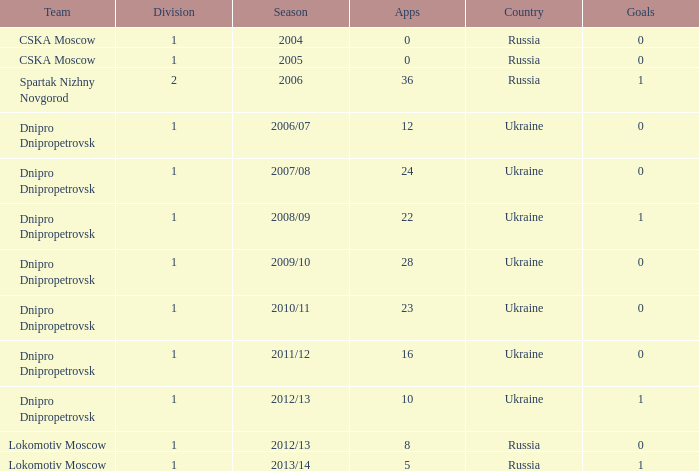Help me parse the entirety of this table. {'header': ['Team', 'Division', 'Season', 'Apps', 'Country', 'Goals'], 'rows': [['CSKA Moscow', '1', '2004', '0', 'Russia', '0'], ['CSKA Moscow', '1', '2005', '0', 'Russia', '0'], ['Spartak Nizhny Novgorod', '2', '2006', '36', 'Russia', '1'], ['Dnipro Dnipropetrovsk', '1', '2006/07', '12', 'Ukraine', '0'], ['Dnipro Dnipropetrovsk', '1', '2007/08', '24', 'Ukraine', '0'], ['Dnipro Dnipropetrovsk', '1', '2008/09', '22', 'Ukraine', '1'], ['Dnipro Dnipropetrovsk', '1', '2009/10', '28', 'Ukraine', '0'], ['Dnipro Dnipropetrovsk', '1', '2010/11', '23', 'Ukraine', '0'], ['Dnipro Dnipropetrovsk', '1', '2011/12', '16', 'Ukraine', '0'], ['Dnipro Dnipropetrovsk', '1', '2012/13', '10', 'Ukraine', '1'], ['Lokomotiv Moscow', '1', '2012/13', '8', 'Russia', '0'], ['Lokomotiv Moscow', '1', '2013/14', '5', 'Russia', '1']]} What division was Ukraine in 2006/07? 1.0. 